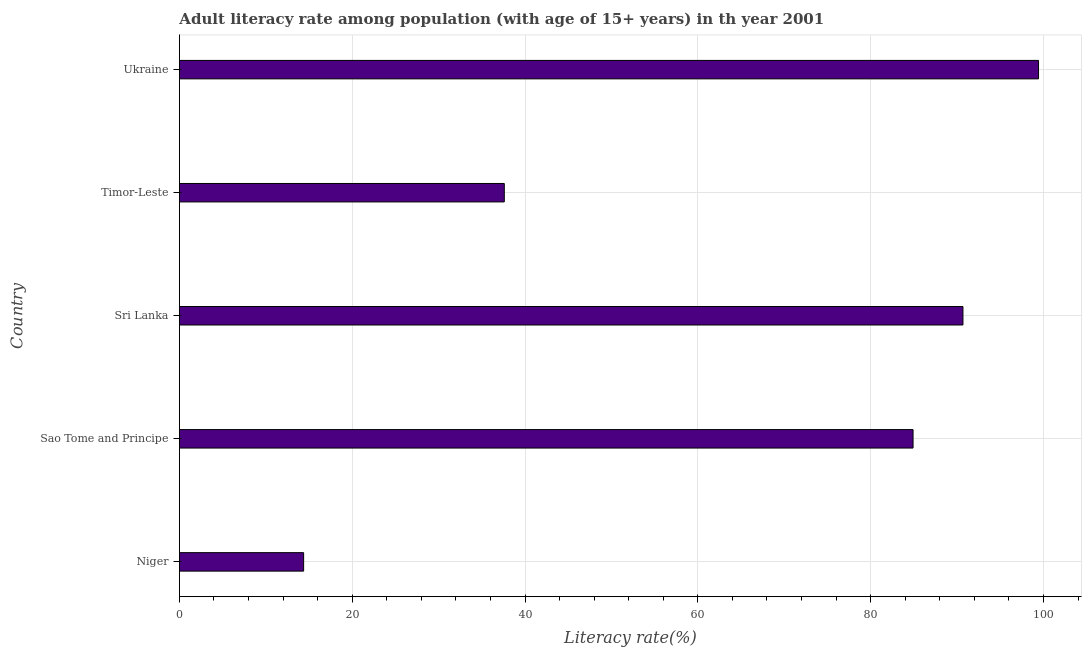Does the graph contain any zero values?
Offer a very short reply. No. Does the graph contain grids?
Offer a terse response. Yes. What is the title of the graph?
Ensure brevity in your answer.  Adult literacy rate among population (with age of 15+ years) in th year 2001. What is the label or title of the X-axis?
Offer a very short reply. Literacy rate(%). What is the label or title of the Y-axis?
Provide a short and direct response. Country. What is the adult literacy rate in Niger?
Your response must be concise. 14.38. Across all countries, what is the maximum adult literacy rate?
Your answer should be compact. 99.43. Across all countries, what is the minimum adult literacy rate?
Ensure brevity in your answer.  14.38. In which country was the adult literacy rate maximum?
Ensure brevity in your answer.  Ukraine. In which country was the adult literacy rate minimum?
Your answer should be compact. Niger. What is the sum of the adult literacy rate?
Give a very brief answer. 327. What is the difference between the adult literacy rate in Timor-Leste and Ukraine?
Ensure brevity in your answer.  -61.83. What is the average adult literacy rate per country?
Your response must be concise. 65.4. What is the median adult literacy rate?
Provide a short and direct response. 84.91. What is the ratio of the adult literacy rate in Sao Tome and Principe to that in Sri Lanka?
Make the answer very short. 0.94. Is the adult literacy rate in Sri Lanka less than that in Ukraine?
Your answer should be very brief. Yes. Is the difference between the adult literacy rate in Sao Tome and Principe and Sri Lanka greater than the difference between any two countries?
Make the answer very short. No. What is the difference between the highest and the second highest adult literacy rate?
Keep it short and to the point. 8.75. Is the sum of the adult literacy rate in Niger and Sri Lanka greater than the maximum adult literacy rate across all countries?
Your response must be concise. Yes. What is the difference between the highest and the lowest adult literacy rate?
Your answer should be very brief. 85.05. How many bars are there?
Offer a very short reply. 5. How many countries are there in the graph?
Your response must be concise. 5. What is the difference between two consecutive major ticks on the X-axis?
Keep it short and to the point. 20. Are the values on the major ticks of X-axis written in scientific E-notation?
Provide a succinct answer. No. What is the Literacy rate(%) of Niger?
Your answer should be very brief. 14.38. What is the Literacy rate(%) of Sao Tome and Principe?
Your response must be concise. 84.91. What is the Literacy rate(%) of Sri Lanka?
Keep it short and to the point. 90.68. What is the Literacy rate(%) in Timor-Leste?
Your answer should be very brief. 37.6. What is the Literacy rate(%) in Ukraine?
Keep it short and to the point. 99.43. What is the difference between the Literacy rate(%) in Niger and Sao Tome and Principe?
Your response must be concise. -70.53. What is the difference between the Literacy rate(%) in Niger and Sri Lanka?
Your response must be concise. -76.31. What is the difference between the Literacy rate(%) in Niger and Timor-Leste?
Make the answer very short. -23.22. What is the difference between the Literacy rate(%) in Niger and Ukraine?
Your answer should be compact. -85.05. What is the difference between the Literacy rate(%) in Sao Tome and Principe and Sri Lanka?
Offer a terse response. -5.77. What is the difference between the Literacy rate(%) in Sao Tome and Principe and Timor-Leste?
Give a very brief answer. 47.31. What is the difference between the Literacy rate(%) in Sao Tome and Principe and Ukraine?
Keep it short and to the point. -14.52. What is the difference between the Literacy rate(%) in Sri Lanka and Timor-Leste?
Ensure brevity in your answer.  53.08. What is the difference between the Literacy rate(%) in Sri Lanka and Ukraine?
Make the answer very short. -8.75. What is the difference between the Literacy rate(%) in Timor-Leste and Ukraine?
Offer a terse response. -61.83. What is the ratio of the Literacy rate(%) in Niger to that in Sao Tome and Principe?
Provide a succinct answer. 0.17. What is the ratio of the Literacy rate(%) in Niger to that in Sri Lanka?
Offer a very short reply. 0.16. What is the ratio of the Literacy rate(%) in Niger to that in Timor-Leste?
Provide a succinct answer. 0.38. What is the ratio of the Literacy rate(%) in Niger to that in Ukraine?
Your answer should be very brief. 0.14. What is the ratio of the Literacy rate(%) in Sao Tome and Principe to that in Sri Lanka?
Provide a succinct answer. 0.94. What is the ratio of the Literacy rate(%) in Sao Tome and Principe to that in Timor-Leste?
Your response must be concise. 2.26. What is the ratio of the Literacy rate(%) in Sao Tome and Principe to that in Ukraine?
Your answer should be compact. 0.85. What is the ratio of the Literacy rate(%) in Sri Lanka to that in Timor-Leste?
Give a very brief answer. 2.41. What is the ratio of the Literacy rate(%) in Sri Lanka to that in Ukraine?
Give a very brief answer. 0.91. What is the ratio of the Literacy rate(%) in Timor-Leste to that in Ukraine?
Provide a short and direct response. 0.38. 